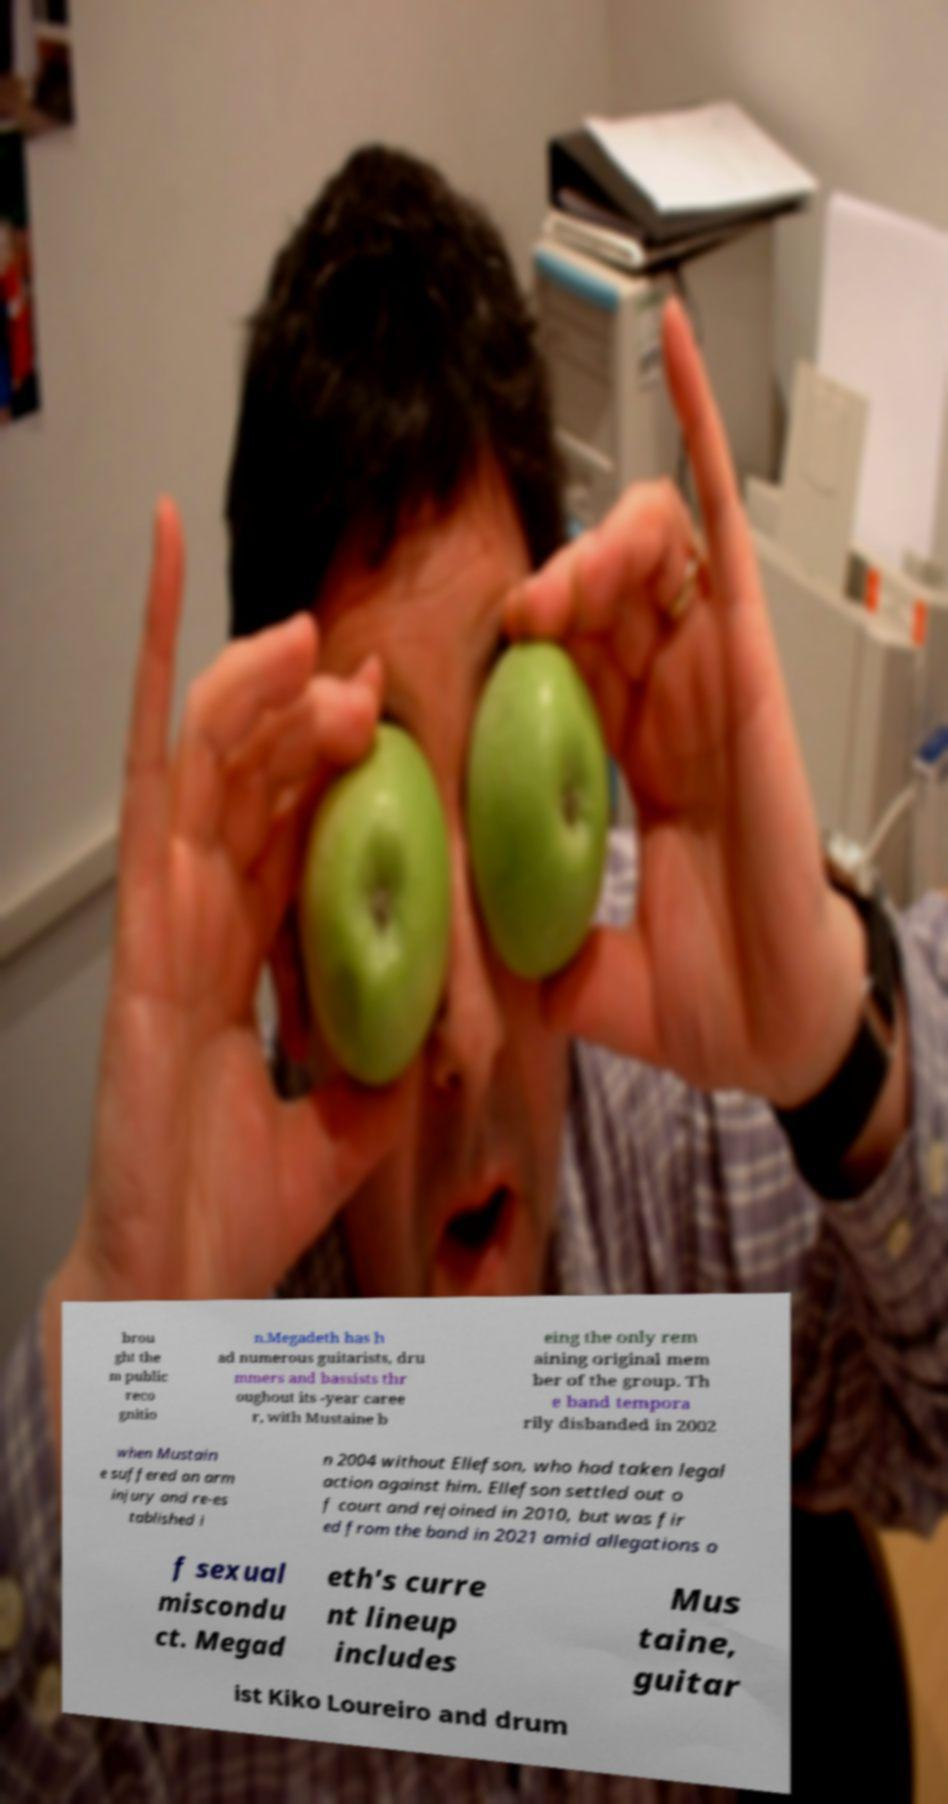What messages or text are displayed in this image? I need them in a readable, typed format. brou ght the m public reco gnitio n.Megadeth has h ad numerous guitarists, dru mmers and bassists thr oughout its -year caree r, with Mustaine b eing the only rem aining original mem ber of the group. Th e band tempora rily disbanded in 2002 when Mustain e suffered an arm injury and re-es tablished i n 2004 without Ellefson, who had taken legal action against him. Ellefson settled out o f court and rejoined in 2010, but was fir ed from the band in 2021 amid allegations o f sexual miscondu ct. Megad eth's curre nt lineup includes Mus taine, guitar ist Kiko Loureiro and drum 